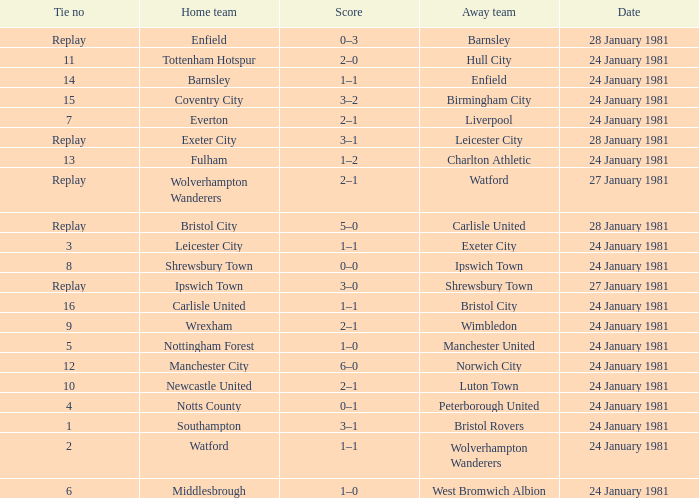What is the score when the tie is 9? 2–1. 